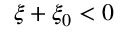<formula> <loc_0><loc_0><loc_500><loc_500>\xi + \xi _ { 0 } < 0</formula> 